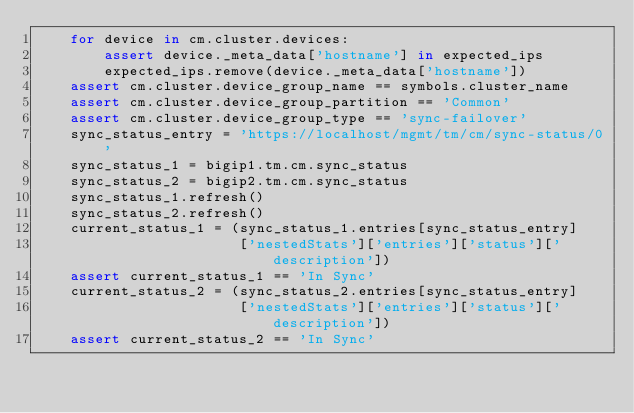Convert code to text. <code><loc_0><loc_0><loc_500><loc_500><_Python_>    for device in cm.cluster.devices:
        assert device._meta_data['hostname'] in expected_ips
        expected_ips.remove(device._meta_data['hostname'])
    assert cm.cluster.device_group_name == symbols.cluster_name
    assert cm.cluster.device_group_partition == 'Common'
    assert cm.cluster.device_group_type == 'sync-failover'
    sync_status_entry = 'https://localhost/mgmt/tm/cm/sync-status/0'
    sync_status_1 = bigip1.tm.cm.sync_status
    sync_status_2 = bigip2.tm.cm.sync_status
    sync_status_1.refresh()
    sync_status_2.refresh()
    current_status_1 = (sync_status_1.entries[sync_status_entry]
                        ['nestedStats']['entries']['status']['description'])
    assert current_status_1 == 'In Sync'
    current_status_2 = (sync_status_2.entries[sync_status_entry]
                        ['nestedStats']['entries']['status']['description'])
    assert current_status_2 == 'In Sync'
</code> 